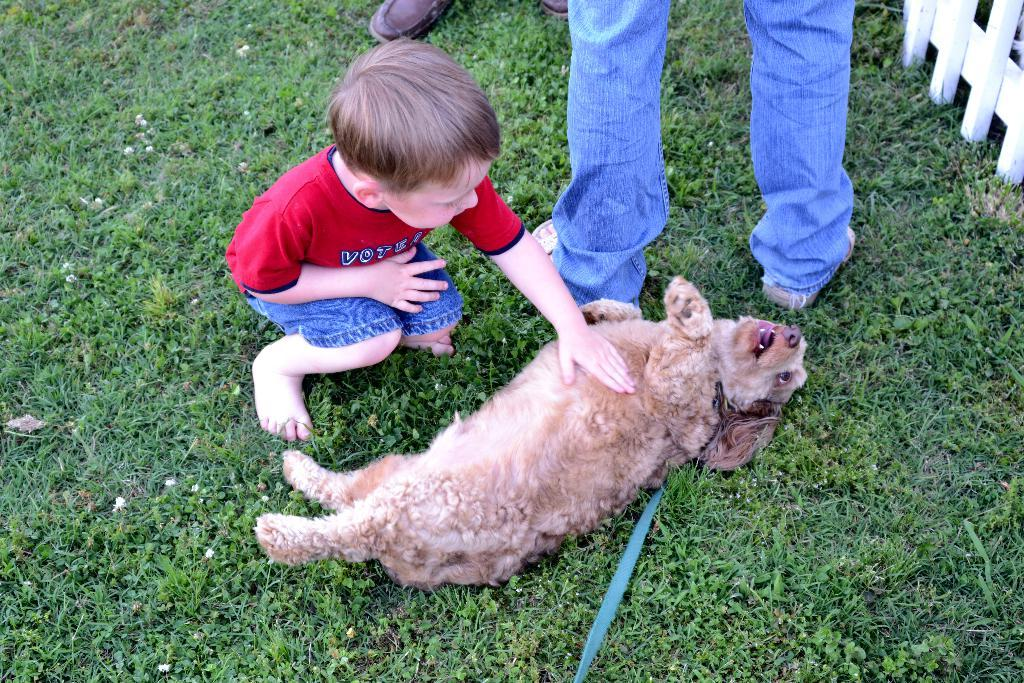Who is the main subject in the image? There is a boy in the image. What is the boy wearing? The boy is wearing a red t-shirt. What type of terrain is visible in the image? There is grass in the image. Are there any animals present in the image? Yes, there is a dog in the image. Whose legs are visible in the image? There are legs of a person visible in the image. How many cattle can be seen grazing in the grass in the image? There are no cattle present in the image; it features a boy, a dog, and a person's legs. What type of kettle is being used to boil water in the image? There is no kettle present in the image. 